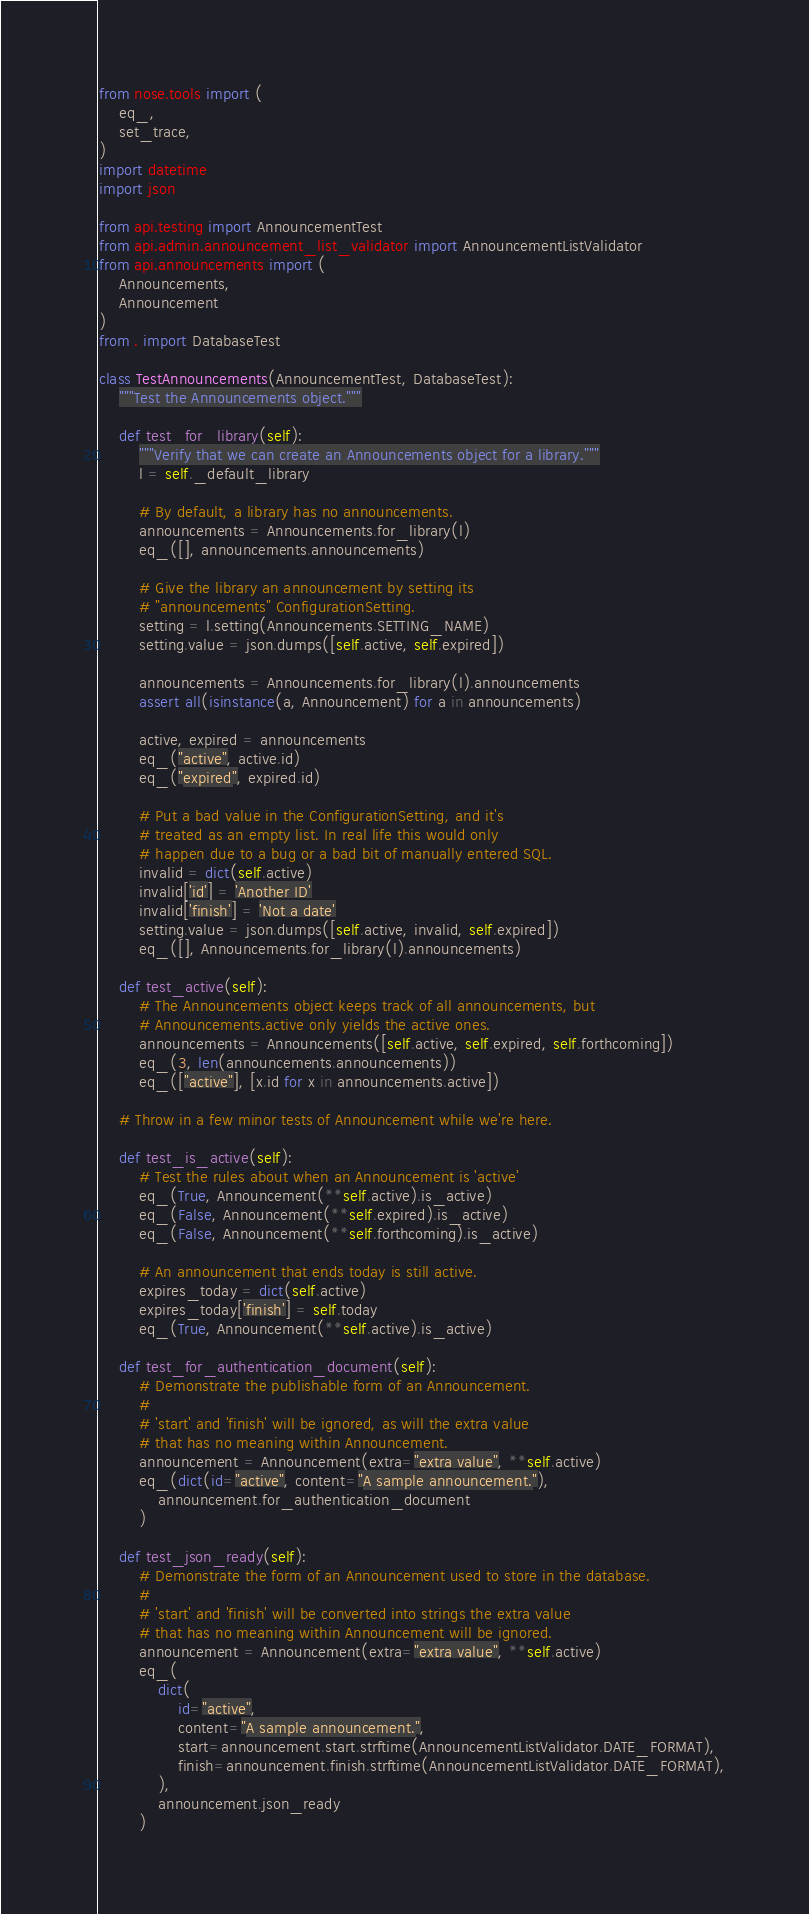<code> <loc_0><loc_0><loc_500><loc_500><_Python_>from nose.tools import (
    eq_,
    set_trace,
)
import datetime
import json

from api.testing import AnnouncementTest
from api.admin.announcement_list_validator import AnnouncementListValidator
from api.announcements import (
    Announcements,
    Announcement
)
from . import DatabaseTest

class TestAnnouncements(AnnouncementTest, DatabaseTest):
    """Test the Announcements object."""

    def test_for_library(self):
        """Verify that we can create an Announcements object for a library."""
        l = self._default_library

        # By default, a library has no announcements.
        announcements = Announcements.for_library(l)
        eq_([], announcements.announcements)

        # Give the library an announcement by setting its
        # "announcements" ConfigurationSetting.
        setting = l.setting(Announcements.SETTING_NAME)
        setting.value = json.dumps([self.active, self.expired])

        announcements = Announcements.for_library(l).announcements
        assert all(isinstance(a, Announcement) for a in announcements)

        active, expired = announcements
        eq_("active", active.id)
        eq_("expired", expired.id)

        # Put a bad value in the ConfigurationSetting, and it's
        # treated as an empty list. In real life this would only
        # happen due to a bug or a bad bit of manually entered SQL.
        invalid = dict(self.active)
        invalid['id'] = 'Another ID'
        invalid['finish'] = 'Not a date'
        setting.value = json.dumps([self.active, invalid, self.expired])
        eq_([], Announcements.for_library(l).announcements)

    def test_active(self):
        # The Announcements object keeps track of all announcements, but
        # Announcements.active only yields the active ones.
        announcements = Announcements([self.active, self.expired, self.forthcoming])
        eq_(3, len(announcements.announcements))
        eq_(["active"], [x.id for x in announcements.active])

    # Throw in a few minor tests of Announcement while we're here.

    def test_is_active(self):
        # Test the rules about when an Announcement is 'active'
        eq_(True, Announcement(**self.active).is_active)
        eq_(False, Announcement(**self.expired).is_active)
        eq_(False, Announcement(**self.forthcoming).is_active)

        # An announcement that ends today is still active.
        expires_today = dict(self.active)
        expires_today['finish'] = self.today
        eq_(True, Announcement(**self.active).is_active)

    def test_for_authentication_document(self):
        # Demonstrate the publishable form of an Announcement.
        #
        # 'start' and 'finish' will be ignored, as will the extra value
        # that has no meaning within Announcement.
        announcement = Announcement(extra="extra value", **self.active)
        eq_(dict(id="active", content="A sample announcement."),
            announcement.for_authentication_document
        )

    def test_json_ready(self):
        # Demonstrate the form of an Announcement used to store in the database.
        #
        # 'start' and 'finish' will be converted into strings the extra value
        # that has no meaning within Announcement will be ignored.
        announcement = Announcement(extra="extra value", **self.active)
        eq_(
            dict(
                id="active",
                content="A sample announcement.",
                start=announcement.start.strftime(AnnouncementListValidator.DATE_FORMAT),
                finish=announcement.finish.strftime(AnnouncementListValidator.DATE_FORMAT),
            ),
            announcement.json_ready
        )
</code> 